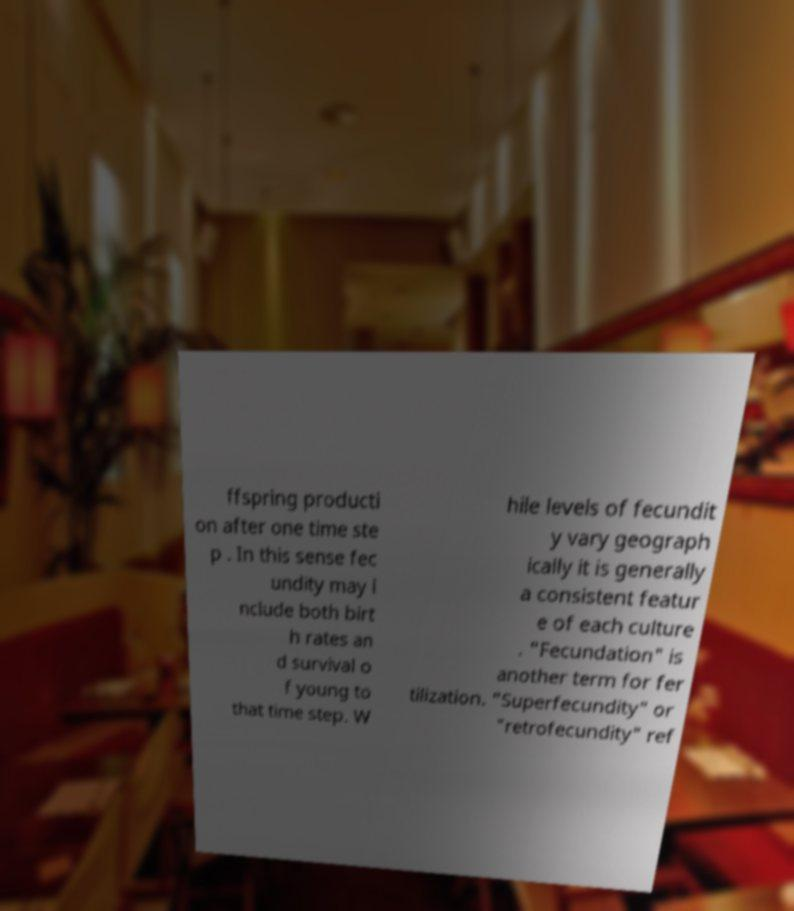Could you assist in decoding the text presented in this image and type it out clearly? ffspring producti on after one time ste p . In this sense fec undity may i nclude both birt h rates an d survival o f young to that time step. W hile levels of fecundit y vary geograph ically it is generally a consistent featur e of each culture . "Fecundation" is another term for fer tilization. "Superfecundity" or "retrofecundity" ref 